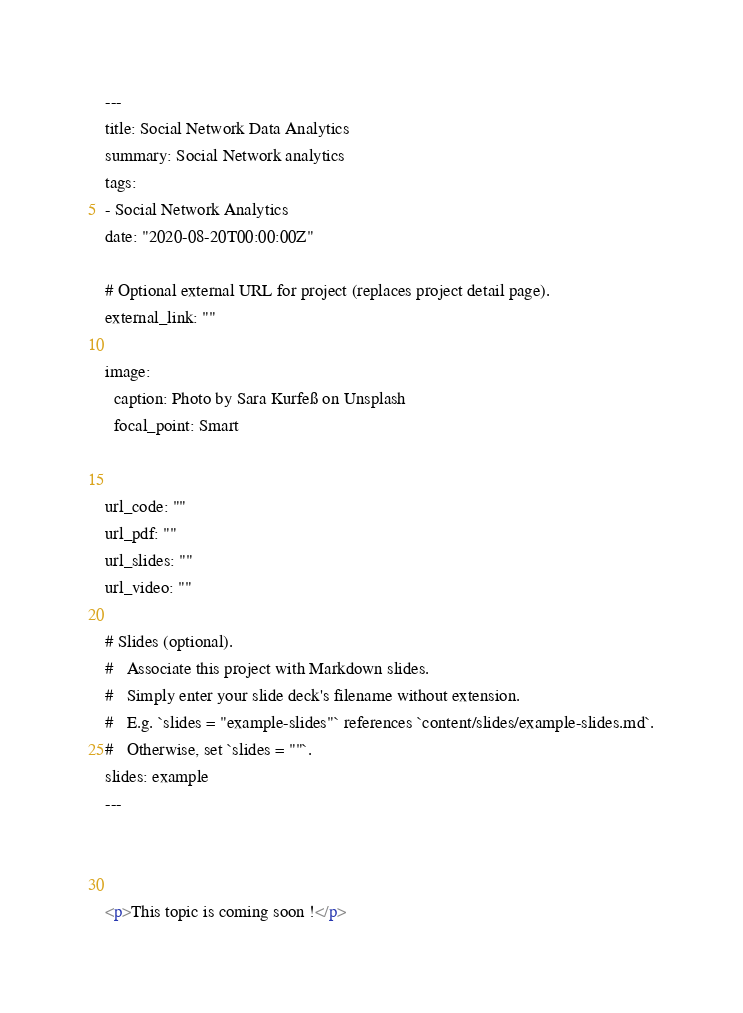<code> <loc_0><loc_0><loc_500><loc_500><_HTML_>---
title: Social Network Data Analytics
summary: Social Network analytics
tags:
- Social Network Analytics
date: "2020-08-20T00:00:00Z"

# Optional external URL for project (replaces project detail page).
external_link: ""

image:
  caption: Photo by Sara Kurfeß on Unsplash
  focal_point: Smart


url_code: ""
url_pdf: ""
url_slides: ""
url_video: ""

# Slides (optional).
#   Associate this project with Markdown slides.
#   Simply enter your slide deck's filename without extension.
#   E.g. `slides = "example-slides"` references `content/slides/example-slides.md`.
#   Otherwise, set `slides = ""`.
slides: example
---



<p>This topic is coming soon !</p>
</code> 